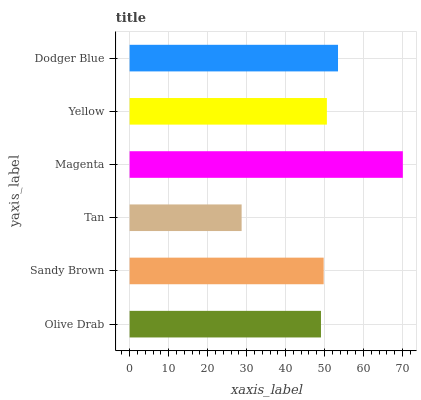Is Tan the minimum?
Answer yes or no. Yes. Is Magenta the maximum?
Answer yes or no. Yes. Is Sandy Brown the minimum?
Answer yes or no. No. Is Sandy Brown the maximum?
Answer yes or no. No. Is Sandy Brown greater than Olive Drab?
Answer yes or no. Yes. Is Olive Drab less than Sandy Brown?
Answer yes or no. Yes. Is Olive Drab greater than Sandy Brown?
Answer yes or no. No. Is Sandy Brown less than Olive Drab?
Answer yes or no. No. Is Yellow the high median?
Answer yes or no. Yes. Is Sandy Brown the low median?
Answer yes or no. Yes. Is Dodger Blue the high median?
Answer yes or no. No. Is Tan the low median?
Answer yes or no. No. 